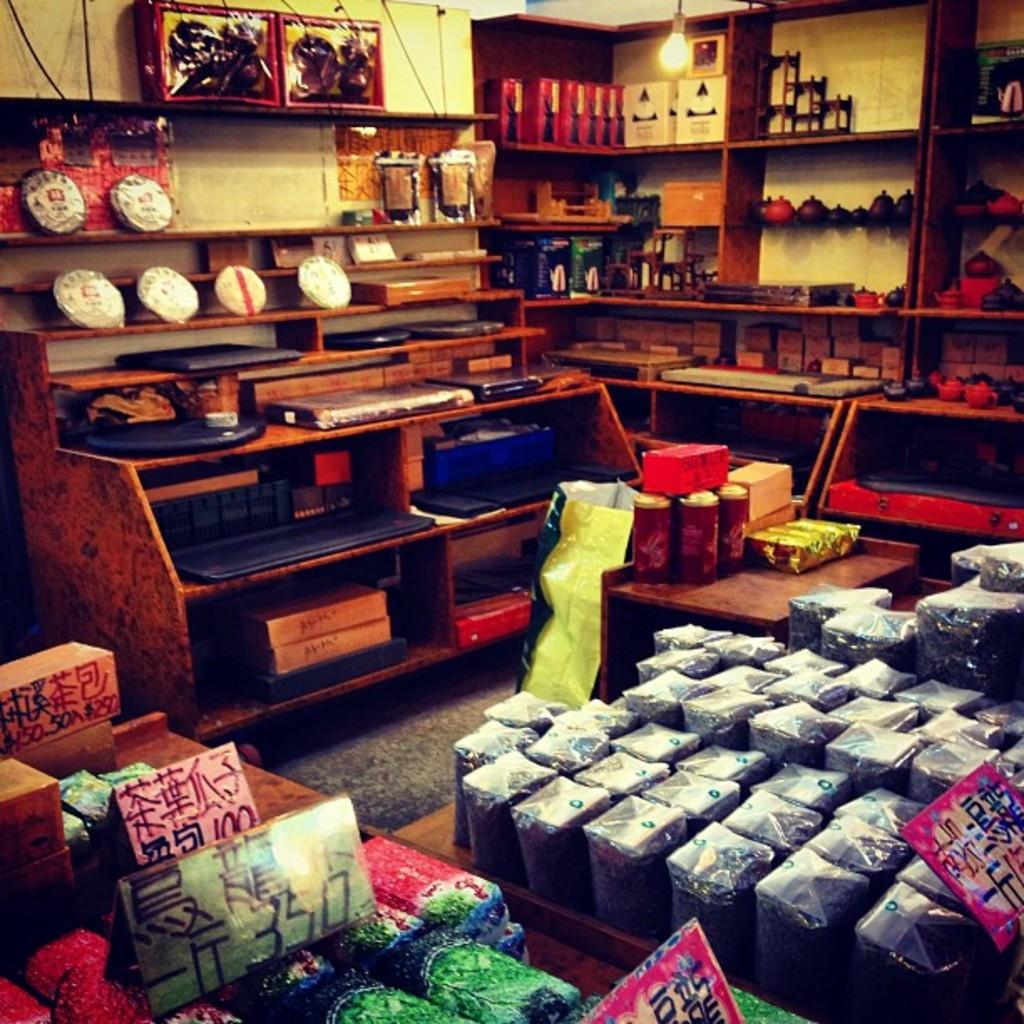<image>
Write a terse but informative summary of the picture. Store products in display bins with a rectangle green sign with 350 in black letters. 